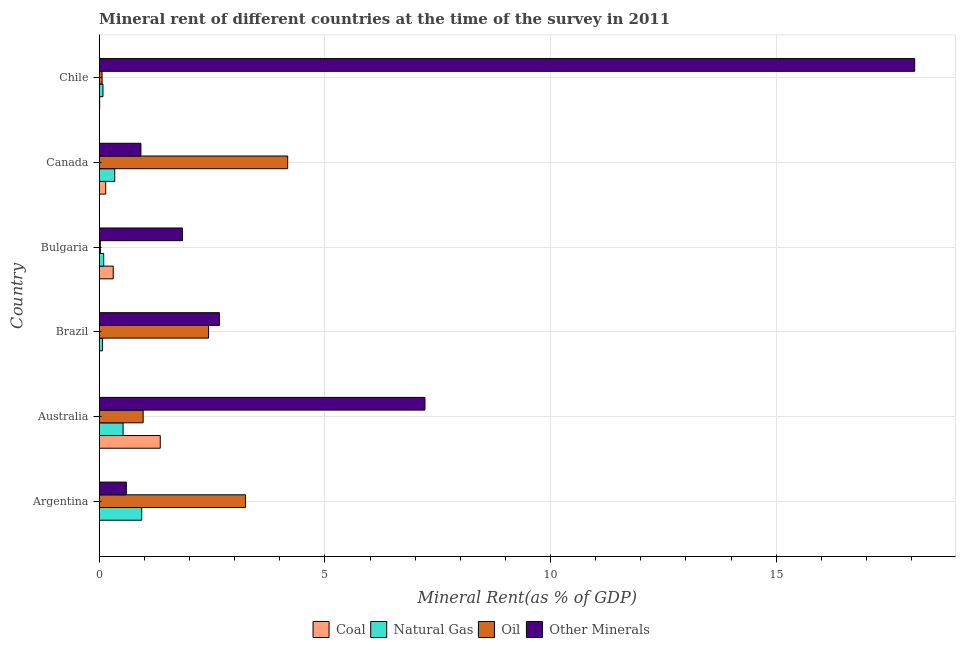How many groups of bars are there?
Provide a short and direct response. 6. Are the number of bars per tick equal to the number of legend labels?
Make the answer very short. Yes. Are the number of bars on each tick of the Y-axis equal?
Ensure brevity in your answer.  Yes. How many bars are there on the 2nd tick from the top?
Provide a succinct answer. 4. What is the natural gas rent in Australia?
Provide a short and direct response. 0.53. Across all countries, what is the maximum natural gas rent?
Give a very brief answer. 0.94. Across all countries, what is the minimum coal rent?
Keep it short and to the point. 0. In which country was the coal rent maximum?
Provide a succinct answer. Australia. In which country was the natural gas rent minimum?
Give a very brief answer. Brazil. What is the total coal rent in the graph?
Ensure brevity in your answer.  1.82. What is the difference between the  rent of other minerals in Argentina and that in Chile?
Offer a very short reply. -17.47. What is the difference between the  rent of other minerals in Australia and the coal rent in Brazil?
Offer a terse response. 7.21. What is the average coal rent per country?
Offer a terse response. 0.3. What is the difference between the oil rent and coal rent in Bulgaria?
Give a very brief answer. -0.29. In how many countries, is the  rent of other minerals greater than 2 %?
Make the answer very short. 3. What is the ratio of the coal rent in Australia to that in Chile?
Ensure brevity in your answer.  144.48. Is the oil rent in Argentina less than that in Bulgaria?
Offer a very short reply. No. What is the difference between the highest and the second highest natural gas rent?
Your response must be concise. 0.41. What is the difference between the highest and the lowest oil rent?
Ensure brevity in your answer.  4.15. In how many countries, is the coal rent greater than the average coal rent taken over all countries?
Ensure brevity in your answer.  2. Is the sum of the oil rent in Bulgaria and Chile greater than the maximum coal rent across all countries?
Provide a short and direct response. No. What does the 2nd bar from the top in Canada represents?
Provide a succinct answer. Oil. What does the 4th bar from the bottom in Chile represents?
Ensure brevity in your answer.  Other Minerals. Is it the case that in every country, the sum of the coal rent and natural gas rent is greater than the oil rent?
Provide a succinct answer. No. Are all the bars in the graph horizontal?
Offer a very short reply. Yes. How many countries are there in the graph?
Keep it short and to the point. 6. What is the difference between two consecutive major ticks on the X-axis?
Offer a terse response. 5. Are the values on the major ticks of X-axis written in scientific E-notation?
Make the answer very short. No. Does the graph contain any zero values?
Provide a short and direct response. No. Does the graph contain grids?
Your answer should be compact. Yes. Where does the legend appear in the graph?
Your response must be concise. Bottom center. How are the legend labels stacked?
Keep it short and to the point. Horizontal. What is the title of the graph?
Your answer should be compact. Mineral rent of different countries at the time of the survey in 2011. What is the label or title of the X-axis?
Provide a succinct answer. Mineral Rent(as % of GDP). What is the Mineral Rent(as % of GDP) in Coal in Argentina?
Make the answer very short. 0. What is the Mineral Rent(as % of GDP) in Natural Gas in Argentina?
Provide a short and direct response. 0.94. What is the Mineral Rent(as % of GDP) of Oil in Argentina?
Ensure brevity in your answer.  3.24. What is the Mineral Rent(as % of GDP) of Other Minerals in Argentina?
Make the answer very short. 0.6. What is the Mineral Rent(as % of GDP) in Coal in Australia?
Give a very brief answer. 1.35. What is the Mineral Rent(as % of GDP) in Natural Gas in Australia?
Your response must be concise. 0.53. What is the Mineral Rent(as % of GDP) in Oil in Australia?
Keep it short and to the point. 0.97. What is the Mineral Rent(as % of GDP) of Other Minerals in Australia?
Provide a short and direct response. 7.22. What is the Mineral Rent(as % of GDP) in Coal in Brazil?
Make the answer very short. 0. What is the Mineral Rent(as % of GDP) in Natural Gas in Brazil?
Offer a very short reply. 0.07. What is the Mineral Rent(as % of GDP) in Oil in Brazil?
Provide a succinct answer. 2.42. What is the Mineral Rent(as % of GDP) of Other Minerals in Brazil?
Your response must be concise. 2.66. What is the Mineral Rent(as % of GDP) of Coal in Bulgaria?
Make the answer very short. 0.31. What is the Mineral Rent(as % of GDP) of Natural Gas in Bulgaria?
Ensure brevity in your answer.  0.1. What is the Mineral Rent(as % of GDP) in Oil in Bulgaria?
Provide a succinct answer. 0.02. What is the Mineral Rent(as % of GDP) in Other Minerals in Bulgaria?
Give a very brief answer. 1.84. What is the Mineral Rent(as % of GDP) in Coal in Canada?
Give a very brief answer. 0.14. What is the Mineral Rent(as % of GDP) in Natural Gas in Canada?
Offer a very short reply. 0.34. What is the Mineral Rent(as % of GDP) of Oil in Canada?
Make the answer very short. 4.18. What is the Mineral Rent(as % of GDP) of Other Minerals in Canada?
Offer a very short reply. 0.92. What is the Mineral Rent(as % of GDP) in Coal in Chile?
Your answer should be very brief. 0.01. What is the Mineral Rent(as % of GDP) in Natural Gas in Chile?
Your answer should be compact. 0.08. What is the Mineral Rent(as % of GDP) of Oil in Chile?
Offer a terse response. 0.06. What is the Mineral Rent(as % of GDP) in Other Minerals in Chile?
Provide a short and direct response. 18.07. Across all countries, what is the maximum Mineral Rent(as % of GDP) of Coal?
Your response must be concise. 1.35. Across all countries, what is the maximum Mineral Rent(as % of GDP) in Natural Gas?
Offer a very short reply. 0.94. Across all countries, what is the maximum Mineral Rent(as % of GDP) in Oil?
Offer a very short reply. 4.18. Across all countries, what is the maximum Mineral Rent(as % of GDP) of Other Minerals?
Your answer should be very brief. 18.07. Across all countries, what is the minimum Mineral Rent(as % of GDP) of Coal?
Offer a terse response. 0. Across all countries, what is the minimum Mineral Rent(as % of GDP) of Natural Gas?
Your answer should be compact. 0.07. Across all countries, what is the minimum Mineral Rent(as % of GDP) in Oil?
Offer a terse response. 0.02. Across all countries, what is the minimum Mineral Rent(as % of GDP) in Other Minerals?
Offer a very short reply. 0.6. What is the total Mineral Rent(as % of GDP) of Coal in the graph?
Your answer should be compact. 1.82. What is the total Mineral Rent(as % of GDP) of Natural Gas in the graph?
Keep it short and to the point. 2.07. What is the total Mineral Rent(as % of GDP) in Oil in the graph?
Your response must be concise. 10.9. What is the total Mineral Rent(as % of GDP) of Other Minerals in the graph?
Ensure brevity in your answer.  31.32. What is the difference between the Mineral Rent(as % of GDP) in Coal in Argentina and that in Australia?
Your answer should be very brief. -1.35. What is the difference between the Mineral Rent(as % of GDP) in Natural Gas in Argentina and that in Australia?
Your answer should be compact. 0.41. What is the difference between the Mineral Rent(as % of GDP) in Oil in Argentina and that in Australia?
Your answer should be compact. 2.27. What is the difference between the Mineral Rent(as % of GDP) in Other Minerals in Argentina and that in Australia?
Make the answer very short. -6.62. What is the difference between the Mineral Rent(as % of GDP) in Coal in Argentina and that in Brazil?
Your answer should be compact. -0. What is the difference between the Mineral Rent(as % of GDP) of Natural Gas in Argentina and that in Brazil?
Offer a very short reply. 0.87. What is the difference between the Mineral Rent(as % of GDP) of Oil in Argentina and that in Brazil?
Offer a terse response. 0.82. What is the difference between the Mineral Rent(as % of GDP) of Other Minerals in Argentina and that in Brazil?
Your answer should be very brief. -2.06. What is the difference between the Mineral Rent(as % of GDP) in Coal in Argentina and that in Bulgaria?
Provide a succinct answer. -0.31. What is the difference between the Mineral Rent(as % of GDP) of Natural Gas in Argentina and that in Bulgaria?
Your answer should be compact. 0.84. What is the difference between the Mineral Rent(as % of GDP) of Oil in Argentina and that in Bulgaria?
Your answer should be compact. 3.22. What is the difference between the Mineral Rent(as % of GDP) in Other Minerals in Argentina and that in Bulgaria?
Make the answer very short. -1.24. What is the difference between the Mineral Rent(as % of GDP) of Coal in Argentina and that in Canada?
Offer a terse response. -0.14. What is the difference between the Mineral Rent(as % of GDP) of Natural Gas in Argentina and that in Canada?
Offer a very short reply. 0.6. What is the difference between the Mineral Rent(as % of GDP) of Oil in Argentina and that in Canada?
Your answer should be compact. -0.94. What is the difference between the Mineral Rent(as % of GDP) of Other Minerals in Argentina and that in Canada?
Provide a short and direct response. -0.32. What is the difference between the Mineral Rent(as % of GDP) in Coal in Argentina and that in Chile?
Your answer should be compact. -0.01. What is the difference between the Mineral Rent(as % of GDP) in Natural Gas in Argentina and that in Chile?
Your answer should be compact. 0.86. What is the difference between the Mineral Rent(as % of GDP) in Oil in Argentina and that in Chile?
Ensure brevity in your answer.  3.18. What is the difference between the Mineral Rent(as % of GDP) of Other Minerals in Argentina and that in Chile?
Your answer should be very brief. -17.47. What is the difference between the Mineral Rent(as % of GDP) of Coal in Australia and that in Brazil?
Give a very brief answer. 1.35. What is the difference between the Mineral Rent(as % of GDP) of Natural Gas in Australia and that in Brazil?
Provide a succinct answer. 0.45. What is the difference between the Mineral Rent(as % of GDP) of Oil in Australia and that in Brazil?
Keep it short and to the point. -1.45. What is the difference between the Mineral Rent(as % of GDP) in Other Minerals in Australia and that in Brazil?
Provide a short and direct response. 4.55. What is the difference between the Mineral Rent(as % of GDP) of Coal in Australia and that in Bulgaria?
Offer a very short reply. 1.04. What is the difference between the Mineral Rent(as % of GDP) in Natural Gas in Australia and that in Bulgaria?
Provide a succinct answer. 0.43. What is the difference between the Mineral Rent(as % of GDP) in Oil in Australia and that in Bulgaria?
Your answer should be compact. 0.95. What is the difference between the Mineral Rent(as % of GDP) in Other Minerals in Australia and that in Bulgaria?
Your answer should be compact. 5.37. What is the difference between the Mineral Rent(as % of GDP) of Coal in Australia and that in Canada?
Offer a terse response. 1.21. What is the difference between the Mineral Rent(as % of GDP) in Natural Gas in Australia and that in Canada?
Make the answer very short. 0.18. What is the difference between the Mineral Rent(as % of GDP) in Oil in Australia and that in Canada?
Offer a terse response. -3.2. What is the difference between the Mineral Rent(as % of GDP) in Other Minerals in Australia and that in Canada?
Your answer should be very brief. 6.29. What is the difference between the Mineral Rent(as % of GDP) in Coal in Australia and that in Chile?
Your answer should be compact. 1.34. What is the difference between the Mineral Rent(as % of GDP) in Natural Gas in Australia and that in Chile?
Offer a terse response. 0.45. What is the difference between the Mineral Rent(as % of GDP) in Oil in Australia and that in Chile?
Provide a short and direct response. 0.91. What is the difference between the Mineral Rent(as % of GDP) in Other Minerals in Australia and that in Chile?
Provide a succinct answer. -10.85. What is the difference between the Mineral Rent(as % of GDP) of Coal in Brazil and that in Bulgaria?
Provide a short and direct response. -0.31. What is the difference between the Mineral Rent(as % of GDP) in Natural Gas in Brazil and that in Bulgaria?
Provide a short and direct response. -0.03. What is the difference between the Mineral Rent(as % of GDP) in Oil in Brazil and that in Bulgaria?
Ensure brevity in your answer.  2.4. What is the difference between the Mineral Rent(as % of GDP) in Other Minerals in Brazil and that in Bulgaria?
Your answer should be compact. 0.82. What is the difference between the Mineral Rent(as % of GDP) in Coal in Brazil and that in Canada?
Provide a short and direct response. -0.14. What is the difference between the Mineral Rent(as % of GDP) of Natural Gas in Brazil and that in Canada?
Your answer should be very brief. -0.27. What is the difference between the Mineral Rent(as % of GDP) in Oil in Brazil and that in Canada?
Give a very brief answer. -1.75. What is the difference between the Mineral Rent(as % of GDP) of Other Minerals in Brazil and that in Canada?
Your response must be concise. 1.74. What is the difference between the Mineral Rent(as % of GDP) of Coal in Brazil and that in Chile?
Provide a short and direct response. -0.01. What is the difference between the Mineral Rent(as % of GDP) of Natural Gas in Brazil and that in Chile?
Offer a terse response. -0.01. What is the difference between the Mineral Rent(as % of GDP) in Oil in Brazil and that in Chile?
Your answer should be compact. 2.36. What is the difference between the Mineral Rent(as % of GDP) in Other Minerals in Brazil and that in Chile?
Your answer should be compact. -15.4. What is the difference between the Mineral Rent(as % of GDP) in Natural Gas in Bulgaria and that in Canada?
Make the answer very short. -0.24. What is the difference between the Mineral Rent(as % of GDP) of Oil in Bulgaria and that in Canada?
Offer a terse response. -4.15. What is the difference between the Mineral Rent(as % of GDP) of Other Minerals in Bulgaria and that in Canada?
Provide a succinct answer. 0.92. What is the difference between the Mineral Rent(as % of GDP) of Coal in Bulgaria and that in Chile?
Ensure brevity in your answer.  0.3. What is the difference between the Mineral Rent(as % of GDP) of Natural Gas in Bulgaria and that in Chile?
Make the answer very short. 0.02. What is the difference between the Mineral Rent(as % of GDP) in Oil in Bulgaria and that in Chile?
Offer a terse response. -0.04. What is the difference between the Mineral Rent(as % of GDP) in Other Minerals in Bulgaria and that in Chile?
Your response must be concise. -16.23. What is the difference between the Mineral Rent(as % of GDP) in Coal in Canada and that in Chile?
Your answer should be compact. 0.13. What is the difference between the Mineral Rent(as % of GDP) in Natural Gas in Canada and that in Chile?
Keep it short and to the point. 0.26. What is the difference between the Mineral Rent(as % of GDP) of Oil in Canada and that in Chile?
Your response must be concise. 4.11. What is the difference between the Mineral Rent(as % of GDP) in Other Minerals in Canada and that in Chile?
Your response must be concise. -17.15. What is the difference between the Mineral Rent(as % of GDP) of Coal in Argentina and the Mineral Rent(as % of GDP) of Natural Gas in Australia?
Provide a succinct answer. -0.53. What is the difference between the Mineral Rent(as % of GDP) of Coal in Argentina and the Mineral Rent(as % of GDP) of Oil in Australia?
Offer a terse response. -0.97. What is the difference between the Mineral Rent(as % of GDP) in Coal in Argentina and the Mineral Rent(as % of GDP) in Other Minerals in Australia?
Give a very brief answer. -7.22. What is the difference between the Mineral Rent(as % of GDP) in Natural Gas in Argentina and the Mineral Rent(as % of GDP) in Oil in Australia?
Your answer should be very brief. -0.03. What is the difference between the Mineral Rent(as % of GDP) in Natural Gas in Argentina and the Mineral Rent(as % of GDP) in Other Minerals in Australia?
Keep it short and to the point. -6.28. What is the difference between the Mineral Rent(as % of GDP) of Oil in Argentina and the Mineral Rent(as % of GDP) of Other Minerals in Australia?
Your answer should be very brief. -3.98. What is the difference between the Mineral Rent(as % of GDP) of Coal in Argentina and the Mineral Rent(as % of GDP) of Natural Gas in Brazil?
Your response must be concise. -0.07. What is the difference between the Mineral Rent(as % of GDP) in Coal in Argentina and the Mineral Rent(as % of GDP) in Oil in Brazil?
Offer a terse response. -2.42. What is the difference between the Mineral Rent(as % of GDP) in Coal in Argentina and the Mineral Rent(as % of GDP) in Other Minerals in Brazil?
Ensure brevity in your answer.  -2.66. What is the difference between the Mineral Rent(as % of GDP) of Natural Gas in Argentina and the Mineral Rent(as % of GDP) of Oil in Brazil?
Offer a terse response. -1.48. What is the difference between the Mineral Rent(as % of GDP) of Natural Gas in Argentina and the Mineral Rent(as % of GDP) of Other Minerals in Brazil?
Your answer should be compact. -1.72. What is the difference between the Mineral Rent(as % of GDP) of Oil in Argentina and the Mineral Rent(as % of GDP) of Other Minerals in Brazil?
Provide a short and direct response. 0.58. What is the difference between the Mineral Rent(as % of GDP) of Coal in Argentina and the Mineral Rent(as % of GDP) of Natural Gas in Bulgaria?
Provide a succinct answer. -0.1. What is the difference between the Mineral Rent(as % of GDP) of Coal in Argentina and the Mineral Rent(as % of GDP) of Oil in Bulgaria?
Ensure brevity in your answer.  -0.02. What is the difference between the Mineral Rent(as % of GDP) in Coal in Argentina and the Mineral Rent(as % of GDP) in Other Minerals in Bulgaria?
Offer a very short reply. -1.84. What is the difference between the Mineral Rent(as % of GDP) of Natural Gas in Argentina and the Mineral Rent(as % of GDP) of Oil in Bulgaria?
Your answer should be compact. 0.92. What is the difference between the Mineral Rent(as % of GDP) of Natural Gas in Argentina and the Mineral Rent(as % of GDP) of Other Minerals in Bulgaria?
Provide a short and direct response. -0.9. What is the difference between the Mineral Rent(as % of GDP) of Oil in Argentina and the Mineral Rent(as % of GDP) of Other Minerals in Bulgaria?
Provide a short and direct response. 1.4. What is the difference between the Mineral Rent(as % of GDP) in Coal in Argentina and the Mineral Rent(as % of GDP) in Natural Gas in Canada?
Offer a terse response. -0.34. What is the difference between the Mineral Rent(as % of GDP) of Coal in Argentina and the Mineral Rent(as % of GDP) of Oil in Canada?
Your answer should be very brief. -4.18. What is the difference between the Mineral Rent(as % of GDP) in Coal in Argentina and the Mineral Rent(as % of GDP) in Other Minerals in Canada?
Provide a succinct answer. -0.92. What is the difference between the Mineral Rent(as % of GDP) in Natural Gas in Argentina and the Mineral Rent(as % of GDP) in Oil in Canada?
Your response must be concise. -3.23. What is the difference between the Mineral Rent(as % of GDP) in Natural Gas in Argentina and the Mineral Rent(as % of GDP) in Other Minerals in Canada?
Keep it short and to the point. 0.02. What is the difference between the Mineral Rent(as % of GDP) in Oil in Argentina and the Mineral Rent(as % of GDP) in Other Minerals in Canada?
Offer a terse response. 2.32. What is the difference between the Mineral Rent(as % of GDP) in Coal in Argentina and the Mineral Rent(as % of GDP) in Natural Gas in Chile?
Make the answer very short. -0.08. What is the difference between the Mineral Rent(as % of GDP) of Coal in Argentina and the Mineral Rent(as % of GDP) of Oil in Chile?
Ensure brevity in your answer.  -0.06. What is the difference between the Mineral Rent(as % of GDP) of Coal in Argentina and the Mineral Rent(as % of GDP) of Other Minerals in Chile?
Your response must be concise. -18.07. What is the difference between the Mineral Rent(as % of GDP) of Natural Gas in Argentina and the Mineral Rent(as % of GDP) of Oil in Chile?
Ensure brevity in your answer.  0.88. What is the difference between the Mineral Rent(as % of GDP) in Natural Gas in Argentina and the Mineral Rent(as % of GDP) in Other Minerals in Chile?
Make the answer very short. -17.13. What is the difference between the Mineral Rent(as % of GDP) in Oil in Argentina and the Mineral Rent(as % of GDP) in Other Minerals in Chile?
Provide a succinct answer. -14.83. What is the difference between the Mineral Rent(as % of GDP) in Coal in Australia and the Mineral Rent(as % of GDP) in Natural Gas in Brazil?
Offer a very short reply. 1.28. What is the difference between the Mineral Rent(as % of GDP) in Coal in Australia and the Mineral Rent(as % of GDP) in Oil in Brazil?
Offer a very short reply. -1.07. What is the difference between the Mineral Rent(as % of GDP) of Coal in Australia and the Mineral Rent(as % of GDP) of Other Minerals in Brazil?
Provide a succinct answer. -1.31. What is the difference between the Mineral Rent(as % of GDP) in Natural Gas in Australia and the Mineral Rent(as % of GDP) in Oil in Brazil?
Give a very brief answer. -1.89. What is the difference between the Mineral Rent(as % of GDP) of Natural Gas in Australia and the Mineral Rent(as % of GDP) of Other Minerals in Brazil?
Provide a short and direct response. -2.14. What is the difference between the Mineral Rent(as % of GDP) of Oil in Australia and the Mineral Rent(as % of GDP) of Other Minerals in Brazil?
Your answer should be very brief. -1.69. What is the difference between the Mineral Rent(as % of GDP) in Coal in Australia and the Mineral Rent(as % of GDP) in Natural Gas in Bulgaria?
Your answer should be compact. 1.25. What is the difference between the Mineral Rent(as % of GDP) in Coal in Australia and the Mineral Rent(as % of GDP) in Oil in Bulgaria?
Ensure brevity in your answer.  1.33. What is the difference between the Mineral Rent(as % of GDP) in Coal in Australia and the Mineral Rent(as % of GDP) in Other Minerals in Bulgaria?
Provide a short and direct response. -0.49. What is the difference between the Mineral Rent(as % of GDP) of Natural Gas in Australia and the Mineral Rent(as % of GDP) of Oil in Bulgaria?
Your answer should be compact. 0.5. What is the difference between the Mineral Rent(as % of GDP) of Natural Gas in Australia and the Mineral Rent(as % of GDP) of Other Minerals in Bulgaria?
Keep it short and to the point. -1.32. What is the difference between the Mineral Rent(as % of GDP) of Oil in Australia and the Mineral Rent(as % of GDP) of Other Minerals in Bulgaria?
Your response must be concise. -0.87. What is the difference between the Mineral Rent(as % of GDP) of Coal in Australia and the Mineral Rent(as % of GDP) of Natural Gas in Canada?
Provide a short and direct response. 1.01. What is the difference between the Mineral Rent(as % of GDP) in Coal in Australia and the Mineral Rent(as % of GDP) in Oil in Canada?
Ensure brevity in your answer.  -2.82. What is the difference between the Mineral Rent(as % of GDP) in Coal in Australia and the Mineral Rent(as % of GDP) in Other Minerals in Canada?
Your answer should be compact. 0.43. What is the difference between the Mineral Rent(as % of GDP) of Natural Gas in Australia and the Mineral Rent(as % of GDP) of Oil in Canada?
Your response must be concise. -3.65. What is the difference between the Mineral Rent(as % of GDP) of Natural Gas in Australia and the Mineral Rent(as % of GDP) of Other Minerals in Canada?
Ensure brevity in your answer.  -0.4. What is the difference between the Mineral Rent(as % of GDP) in Oil in Australia and the Mineral Rent(as % of GDP) in Other Minerals in Canada?
Give a very brief answer. 0.05. What is the difference between the Mineral Rent(as % of GDP) of Coal in Australia and the Mineral Rent(as % of GDP) of Natural Gas in Chile?
Your answer should be very brief. 1.27. What is the difference between the Mineral Rent(as % of GDP) of Coal in Australia and the Mineral Rent(as % of GDP) of Oil in Chile?
Ensure brevity in your answer.  1.29. What is the difference between the Mineral Rent(as % of GDP) in Coal in Australia and the Mineral Rent(as % of GDP) in Other Minerals in Chile?
Your answer should be very brief. -16.72. What is the difference between the Mineral Rent(as % of GDP) in Natural Gas in Australia and the Mineral Rent(as % of GDP) in Oil in Chile?
Ensure brevity in your answer.  0.47. What is the difference between the Mineral Rent(as % of GDP) in Natural Gas in Australia and the Mineral Rent(as % of GDP) in Other Minerals in Chile?
Provide a succinct answer. -17.54. What is the difference between the Mineral Rent(as % of GDP) in Oil in Australia and the Mineral Rent(as % of GDP) in Other Minerals in Chile?
Your answer should be very brief. -17.1. What is the difference between the Mineral Rent(as % of GDP) of Coal in Brazil and the Mineral Rent(as % of GDP) of Natural Gas in Bulgaria?
Your response must be concise. -0.1. What is the difference between the Mineral Rent(as % of GDP) of Coal in Brazil and the Mineral Rent(as % of GDP) of Oil in Bulgaria?
Make the answer very short. -0.02. What is the difference between the Mineral Rent(as % of GDP) of Coal in Brazil and the Mineral Rent(as % of GDP) of Other Minerals in Bulgaria?
Your response must be concise. -1.84. What is the difference between the Mineral Rent(as % of GDP) of Natural Gas in Brazil and the Mineral Rent(as % of GDP) of Oil in Bulgaria?
Make the answer very short. 0.05. What is the difference between the Mineral Rent(as % of GDP) in Natural Gas in Brazil and the Mineral Rent(as % of GDP) in Other Minerals in Bulgaria?
Offer a terse response. -1.77. What is the difference between the Mineral Rent(as % of GDP) in Oil in Brazil and the Mineral Rent(as % of GDP) in Other Minerals in Bulgaria?
Make the answer very short. 0.58. What is the difference between the Mineral Rent(as % of GDP) of Coal in Brazil and the Mineral Rent(as % of GDP) of Natural Gas in Canada?
Offer a very short reply. -0.34. What is the difference between the Mineral Rent(as % of GDP) in Coal in Brazil and the Mineral Rent(as % of GDP) in Oil in Canada?
Ensure brevity in your answer.  -4.17. What is the difference between the Mineral Rent(as % of GDP) in Coal in Brazil and the Mineral Rent(as % of GDP) in Other Minerals in Canada?
Provide a succinct answer. -0.92. What is the difference between the Mineral Rent(as % of GDP) in Natural Gas in Brazil and the Mineral Rent(as % of GDP) in Oil in Canada?
Your answer should be compact. -4.1. What is the difference between the Mineral Rent(as % of GDP) in Natural Gas in Brazil and the Mineral Rent(as % of GDP) in Other Minerals in Canada?
Your answer should be compact. -0.85. What is the difference between the Mineral Rent(as % of GDP) of Oil in Brazil and the Mineral Rent(as % of GDP) of Other Minerals in Canada?
Offer a terse response. 1.5. What is the difference between the Mineral Rent(as % of GDP) in Coal in Brazil and the Mineral Rent(as % of GDP) in Natural Gas in Chile?
Your answer should be very brief. -0.08. What is the difference between the Mineral Rent(as % of GDP) of Coal in Brazil and the Mineral Rent(as % of GDP) of Oil in Chile?
Your response must be concise. -0.06. What is the difference between the Mineral Rent(as % of GDP) in Coal in Brazil and the Mineral Rent(as % of GDP) in Other Minerals in Chile?
Give a very brief answer. -18.07. What is the difference between the Mineral Rent(as % of GDP) in Natural Gas in Brazil and the Mineral Rent(as % of GDP) in Oil in Chile?
Give a very brief answer. 0.01. What is the difference between the Mineral Rent(as % of GDP) of Natural Gas in Brazil and the Mineral Rent(as % of GDP) of Other Minerals in Chile?
Keep it short and to the point. -18. What is the difference between the Mineral Rent(as % of GDP) of Oil in Brazil and the Mineral Rent(as % of GDP) of Other Minerals in Chile?
Your answer should be compact. -15.65. What is the difference between the Mineral Rent(as % of GDP) of Coal in Bulgaria and the Mineral Rent(as % of GDP) of Natural Gas in Canada?
Provide a succinct answer. -0.03. What is the difference between the Mineral Rent(as % of GDP) in Coal in Bulgaria and the Mineral Rent(as % of GDP) in Oil in Canada?
Your answer should be compact. -3.87. What is the difference between the Mineral Rent(as % of GDP) in Coal in Bulgaria and the Mineral Rent(as % of GDP) in Other Minerals in Canada?
Provide a succinct answer. -0.61. What is the difference between the Mineral Rent(as % of GDP) in Natural Gas in Bulgaria and the Mineral Rent(as % of GDP) in Oil in Canada?
Provide a succinct answer. -4.08. What is the difference between the Mineral Rent(as % of GDP) of Natural Gas in Bulgaria and the Mineral Rent(as % of GDP) of Other Minerals in Canada?
Provide a succinct answer. -0.82. What is the difference between the Mineral Rent(as % of GDP) of Oil in Bulgaria and the Mineral Rent(as % of GDP) of Other Minerals in Canada?
Ensure brevity in your answer.  -0.9. What is the difference between the Mineral Rent(as % of GDP) in Coal in Bulgaria and the Mineral Rent(as % of GDP) in Natural Gas in Chile?
Your answer should be very brief. 0.23. What is the difference between the Mineral Rent(as % of GDP) in Coal in Bulgaria and the Mineral Rent(as % of GDP) in Oil in Chile?
Your answer should be compact. 0.25. What is the difference between the Mineral Rent(as % of GDP) in Coal in Bulgaria and the Mineral Rent(as % of GDP) in Other Minerals in Chile?
Ensure brevity in your answer.  -17.76. What is the difference between the Mineral Rent(as % of GDP) in Natural Gas in Bulgaria and the Mineral Rent(as % of GDP) in Oil in Chile?
Provide a short and direct response. 0.04. What is the difference between the Mineral Rent(as % of GDP) of Natural Gas in Bulgaria and the Mineral Rent(as % of GDP) of Other Minerals in Chile?
Keep it short and to the point. -17.97. What is the difference between the Mineral Rent(as % of GDP) in Oil in Bulgaria and the Mineral Rent(as % of GDP) in Other Minerals in Chile?
Offer a very short reply. -18.05. What is the difference between the Mineral Rent(as % of GDP) in Coal in Canada and the Mineral Rent(as % of GDP) in Natural Gas in Chile?
Your answer should be very brief. 0.06. What is the difference between the Mineral Rent(as % of GDP) in Coal in Canada and the Mineral Rent(as % of GDP) in Oil in Chile?
Offer a terse response. 0.08. What is the difference between the Mineral Rent(as % of GDP) of Coal in Canada and the Mineral Rent(as % of GDP) of Other Minerals in Chile?
Ensure brevity in your answer.  -17.93. What is the difference between the Mineral Rent(as % of GDP) of Natural Gas in Canada and the Mineral Rent(as % of GDP) of Oil in Chile?
Your answer should be compact. 0.28. What is the difference between the Mineral Rent(as % of GDP) in Natural Gas in Canada and the Mineral Rent(as % of GDP) in Other Minerals in Chile?
Your response must be concise. -17.73. What is the difference between the Mineral Rent(as % of GDP) in Oil in Canada and the Mineral Rent(as % of GDP) in Other Minerals in Chile?
Your answer should be very brief. -13.89. What is the average Mineral Rent(as % of GDP) of Coal per country?
Make the answer very short. 0.3. What is the average Mineral Rent(as % of GDP) in Natural Gas per country?
Provide a succinct answer. 0.35. What is the average Mineral Rent(as % of GDP) of Oil per country?
Ensure brevity in your answer.  1.82. What is the average Mineral Rent(as % of GDP) in Other Minerals per country?
Provide a succinct answer. 5.22. What is the difference between the Mineral Rent(as % of GDP) in Coal and Mineral Rent(as % of GDP) in Natural Gas in Argentina?
Your answer should be compact. -0.94. What is the difference between the Mineral Rent(as % of GDP) of Coal and Mineral Rent(as % of GDP) of Oil in Argentina?
Offer a terse response. -3.24. What is the difference between the Mineral Rent(as % of GDP) in Coal and Mineral Rent(as % of GDP) in Other Minerals in Argentina?
Provide a succinct answer. -0.6. What is the difference between the Mineral Rent(as % of GDP) of Natural Gas and Mineral Rent(as % of GDP) of Oil in Argentina?
Offer a very short reply. -2.3. What is the difference between the Mineral Rent(as % of GDP) of Natural Gas and Mineral Rent(as % of GDP) of Other Minerals in Argentina?
Keep it short and to the point. 0.34. What is the difference between the Mineral Rent(as % of GDP) of Oil and Mineral Rent(as % of GDP) of Other Minerals in Argentina?
Offer a very short reply. 2.64. What is the difference between the Mineral Rent(as % of GDP) of Coal and Mineral Rent(as % of GDP) of Natural Gas in Australia?
Your response must be concise. 0.82. What is the difference between the Mineral Rent(as % of GDP) of Coal and Mineral Rent(as % of GDP) of Oil in Australia?
Keep it short and to the point. 0.38. What is the difference between the Mineral Rent(as % of GDP) in Coal and Mineral Rent(as % of GDP) in Other Minerals in Australia?
Keep it short and to the point. -5.87. What is the difference between the Mineral Rent(as % of GDP) of Natural Gas and Mineral Rent(as % of GDP) of Oil in Australia?
Your answer should be very brief. -0.44. What is the difference between the Mineral Rent(as % of GDP) of Natural Gas and Mineral Rent(as % of GDP) of Other Minerals in Australia?
Keep it short and to the point. -6.69. What is the difference between the Mineral Rent(as % of GDP) of Oil and Mineral Rent(as % of GDP) of Other Minerals in Australia?
Provide a short and direct response. -6.24. What is the difference between the Mineral Rent(as % of GDP) in Coal and Mineral Rent(as % of GDP) in Natural Gas in Brazil?
Provide a succinct answer. -0.07. What is the difference between the Mineral Rent(as % of GDP) of Coal and Mineral Rent(as % of GDP) of Oil in Brazil?
Provide a short and direct response. -2.42. What is the difference between the Mineral Rent(as % of GDP) of Coal and Mineral Rent(as % of GDP) of Other Minerals in Brazil?
Your answer should be very brief. -2.66. What is the difference between the Mineral Rent(as % of GDP) in Natural Gas and Mineral Rent(as % of GDP) in Oil in Brazil?
Make the answer very short. -2.35. What is the difference between the Mineral Rent(as % of GDP) of Natural Gas and Mineral Rent(as % of GDP) of Other Minerals in Brazil?
Offer a very short reply. -2.59. What is the difference between the Mineral Rent(as % of GDP) of Oil and Mineral Rent(as % of GDP) of Other Minerals in Brazil?
Provide a succinct answer. -0.24. What is the difference between the Mineral Rent(as % of GDP) of Coal and Mineral Rent(as % of GDP) of Natural Gas in Bulgaria?
Keep it short and to the point. 0.21. What is the difference between the Mineral Rent(as % of GDP) in Coal and Mineral Rent(as % of GDP) in Oil in Bulgaria?
Give a very brief answer. 0.29. What is the difference between the Mineral Rent(as % of GDP) in Coal and Mineral Rent(as % of GDP) in Other Minerals in Bulgaria?
Your answer should be very brief. -1.53. What is the difference between the Mineral Rent(as % of GDP) in Natural Gas and Mineral Rent(as % of GDP) in Oil in Bulgaria?
Your answer should be compact. 0.08. What is the difference between the Mineral Rent(as % of GDP) of Natural Gas and Mineral Rent(as % of GDP) of Other Minerals in Bulgaria?
Provide a succinct answer. -1.75. What is the difference between the Mineral Rent(as % of GDP) in Oil and Mineral Rent(as % of GDP) in Other Minerals in Bulgaria?
Give a very brief answer. -1.82. What is the difference between the Mineral Rent(as % of GDP) of Coal and Mineral Rent(as % of GDP) of Natural Gas in Canada?
Ensure brevity in your answer.  -0.2. What is the difference between the Mineral Rent(as % of GDP) of Coal and Mineral Rent(as % of GDP) of Oil in Canada?
Offer a very short reply. -4.03. What is the difference between the Mineral Rent(as % of GDP) in Coal and Mineral Rent(as % of GDP) in Other Minerals in Canada?
Give a very brief answer. -0.78. What is the difference between the Mineral Rent(as % of GDP) of Natural Gas and Mineral Rent(as % of GDP) of Oil in Canada?
Your answer should be very brief. -3.83. What is the difference between the Mineral Rent(as % of GDP) in Natural Gas and Mineral Rent(as % of GDP) in Other Minerals in Canada?
Offer a terse response. -0.58. What is the difference between the Mineral Rent(as % of GDP) of Oil and Mineral Rent(as % of GDP) of Other Minerals in Canada?
Ensure brevity in your answer.  3.25. What is the difference between the Mineral Rent(as % of GDP) of Coal and Mineral Rent(as % of GDP) of Natural Gas in Chile?
Provide a succinct answer. -0.07. What is the difference between the Mineral Rent(as % of GDP) of Coal and Mineral Rent(as % of GDP) of Oil in Chile?
Offer a terse response. -0.05. What is the difference between the Mineral Rent(as % of GDP) in Coal and Mineral Rent(as % of GDP) in Other Minerals in Chile?
Ensure brevity in your answer.  -18.06. What is the difference between the Mineral Rent(as % of GDP) in Natural Gas and Mineral Rent(as % of GDP) in Oil in Chile?
Make the answer very short. 0.02. What is the difference between the Mineral Rent(as % of GDP) in Natural Gas and Mineral Rent(as % of GDP) in Other Minerals in Chile?
Keep it short and to the point. -17.99. What is the difference between the Mineral Rent(as % of GDP) in Oil and Mineral Rent(as % of GDP) in Other Minerals in Chile?
Give a very brief answer. -18.01. What is the ratio of the Mineral Rent(as % of GDP) in Coal in Argentina to that in Australia?
Ensure brevity in your answer.  0. What is the ratio of the Mineral Rent(as % of GDP) in Natural Gas in Argentina to that in Australia?
Your answer should be very brief. 1.78. What is the ratio of the Mineral Rent(as % of GDP) in Oil in Argentina to that in Australia?
Your response must be concise. 3.33. What is the ratio of the Mineral Rent(as % of GDP) of Other Minerals in Argentina to that in Australia?
Your answer should be compact. 0.08. What is the ratio of the Mineral Rent(as % of GDP) of Coal in Argentina to that in Brazil?
Make the answer very short. 0.24. What is the ratio of the Mineral Rent(as % of GDP) in Natural Gas in Argentina to that in Brazil?
Provide a short and direct response. 12.7. What is the ratio of the Mineral Rent(as % of GDP) in Oil in Argentina to that in Brazil?
Ensure brevity in your answer.  1.34. What is the ratio of the Mineral Rent(as % of GDP) of Other Minerals in Argentina to that in Brazil?
Offer a very short reply. 0.23. What is the ratio of the Mineral Rent(as % of GDP) of Coal in Argentina to that in Bulgaria?
Keep it short and to the point. 0. What is the ratio of the Mineral Rent(as % of GDP) in Natural Gas in Argentina to that in Bulgaria?
Give a very brief answer. 9.46. What is the ratio of the Mineral Rent(as % of GDP) of Oil in Argentina to that in Bulgaria?
Your answer should be very brief. 133.18. What is the ratio of the Mineral Rent(as % of GDP) in Other Minerals in Argentina to that in Bulgaria?
Offer a very short reply. 0.33. What is the ratio of the Mineral Rent(as % of GDP) in Coal in Argentina to that in Canada?
Offer a very short reply. 0.01. What is the ratio of the Mineral Rent(as % of GDP) in Natural Gas in Argentina to that in Canada?
Your response must be concise. 2.74. What is the ratio of the Mineral Rent(as % of GDP) in Oil in Argentina to that in Canada?
Your answer should be compact. 0.78. What is the ratio of the Mineral Rent(as % of GDP) of Other Minerals in Argentina to that in Canada?
Give a very brief answer. 0.65. What is the ratio of the Mineral Rent(as % of GDP) of Coal in Argentina to that in Chile?
Keep it short and to the point. 0.1. What is the ratio of the Mineral Rent(as % of GDP) in Natural Gas in Argentina to that in Chile?
Give a very brief answer. 11.31. What is the ratio of the Mineral Rent(as % of GDP) in Oil in Argentina to that in Chile?
Your response must be concise. 51.23. What is the ratio of the Mineral Rent(as % of GDP) in Other Minerals in Argentina to that in Chile?
Your response must be concise. 0.03. What is the ratio of the Mineral Rent(as % of GDP) of Coal in Australia to that in Brazil?
Keep it short and to the point. 364.89. What is the ratio of the Mineral Rent(as % of GDP) of Natural Gas in Australia to that in Brazil?
Ensure brevity in your answer.  7.13. What is the ratio of the Mineral Rent(as % of GDP) in Oil in Australia to that in Brazil?
Give a very brief answer. 0.4. What is the ratio of the Mineral Rent(as % of GDP) in Other Minerals in Australia to that in Brazil?
Give a very brief answer. 2.71. What is the ratio of the Mineral Rent(as % of GDP) in Coal in Australia to that in Bulgaria?
Offer a terse response. 4.36. What is the ratio of the Mineral Rent(as % of GDP) of Natural Gas in Australia to that in Bulgaria?
Ensure brevity in your answer.  5.31. What is the ratio of the Mineral Rent(as % of GDP) of Oil in Australia to that in Bulgaria?
Your answer should be very brief. 40.02. What is the ratio of the Mineral Rent(as % of GDP) of Other Minerals in Australia to that in Bulgaria?
Offer a terse response. 3.91. What is the ratio of the Mineral Rent(as % of GDP) of Coal in Australia to that in Canada?
Make the answer very short. 9.41. What is the ratio of the Mineral Rent(as % of GDP) in Natural Gas in Australia to that in Canada?
Provide a short and direct response. 1.54. What is the ratio of the Mineral Rent(as % of GDP) of Oil in Australia to that in Canada?
Your answer should be compact. 0.23. What is the ratio of the Mineral Rent(as % of GDP) in Other Minerals in Australia to that in Canada?
Your response must be concise. 7.81. What is the ratio of the Mineral Rent(as % of GDP) in Coal in Australia to that in Chile?
Make the answer very short. 144.48. What is the ratio of the Mineral Rent(as % of GDP) of Natural Gas in Australia to that in Chile?
Keep it short and to the point. 6.35. What is the ratio of the Mineral Rent(as % of GDP) in Oil in Australia to that in Chile?
Provide a succinct answer. 15.39. What is the ratio of the Mineral Rent(as % of GDP) in Other Minerals in Australia to that in Chile?
Offer a very short reply. 0.4. What is the ratio of the Mineral Rent(as % of GDP) of Coal in Brazil to that in Bulgaria?
Your response must be concise. 0.01. What is the ratio of the Mineral Rent(as % of GDP) of Natural Gas in Brazil to that in Bulgaria?
Your answer should be compact. 0.74. What is the ratio of the Mineral Rent(as % of GDP) of Oil in Brazil to that in Bulgaria?
Your answer should be very brief. 99.58. What is the ratio of the Mineral Rent(as % of GDP) of Other Minerals in Brazil to that in Bulgaria?
Give a very brief answer. 1.44. What is the ratio of the Mineral Rent(as % of GDP) in Coal in Brazil to that in Canada?
Provide a succinct answer. 0.03. What is the ratio of the Mineral Rent(as % of GDP) in Natural Gas in Brazil to that in Canada?
Ensure brevity in your answer.  0.22. What is the ratio of the Mineral Rent(as % of GDP) in Oil in Brazil to that in Canada?
Your response must be concise. 0.58. What is the ratio of the Mineral Rent(as % of GDP) in Other Minerals in Brazil to that in Canada?
Your answer should be very brief. 2.88. What is the ratio of the Mineral Rent(as % of GDP) of Coal in Brazil to that in Chile?
Make the answer very short. 0.4. What is the ratio of the Mineral Rent(as % of GDP) of Natural Gas in Brazil to that in Chile?
Offer a very short reply. 0.89. What is the ratio of the Mineral Rent(as % of GDP) in Oil in Brazil to that in Chile?
Offer a very short reply. 38.31. What is the ratio of the Mineral Rent(as % of GDP) of Other Minerals in Brazil to that in Chile?
Ensure brevity in your answer.  0.15. What is the ratio of the Mineral Rent(as % of GDP) in Coal in Bulgaria to that in Canada?
Offer a terse response. 2.16. What is the ratio of the Mineral Rent(as % of GDP) of Natural Gas in Bulgaria to that in Canada?
Your answer should be very brief. 0.29. What is the ratio of the Mineral Rent(as % of GDP) of Oil in Bulgaria to that in Canada?
Offer a very short reply. 0.01. What is the ratio of the Mineral Rent(as % of GDP) of Other Minerals in Bulgaria to that in Canada?
Your answer should be compact. 2. What is the ratio of the Mineral Rent(as % of GDP) in Coal in Bulgaria to that in Chile?
Give a very brief answer. 33.16. What is the ratio of the Mineral Rent(as % of GDP) in Natural Gas in Bulgaria to that in Chile?
Make the answer very short. 1.2. What is the ratio of the Mineral Rent(as % of GDP) in Oil in Bulgaria to that in Chile?
Give a very brief answer. 0.38. What is the ratio of the Mineral Rent(as % of GDP) of Other Minerals in Bulgaria to that in Chile?
Keep it short and to the point. 0.1. What is the ratio of the Mineral Rent(as % of GDP) in Coal in Canada to that in Chile?
Keep it short and to the point. 15.36. What is the ratio of the Mineral Rent(as % of GDP) in Natural Gas in Canada to that in Chile?
Your answer should be very brief. 4.13. What is the ratio of the Mineral Rent(as % of GDP) of Oil in Canada to that in Chile?
Your answer should be very brief. 66.02. What is the ratio of the Mineral Rent(as % of GDP) of Other Minerals in Canada to that in Chile?
Ensure brevity in your answer.  0.05. What is the difference between the highest and the second highest Mineral Rent(as % of GDP) of Coal?
Offer a very short reply. 1.04. What is the difference between the highest and the second highest Mineral Rent(as % of GDP) in Natural Gas?
Ensure brevity in your answer.  0.41. What is the difference between the highest and the second highest Mineral Rent(as % of GDP) in Oil?
Your answer should be compact. 0.94. What is the difference between the highest and the second highest Mineral Rent(as % of GDP) of Other Minerals?
Give a very brief answer. 10.85. What is the difference between the highest and the lowest Mineral Rent(as % of GDP) in Coal?
Your answer should be very brief. 1.35. What is the difference between the highest and the lowest Mineral Rent(as % of GDP) of Natural Gas?
Offer a very short reply. 0.87. What is the difference between the highest and the lowest Mineral Rent(as % of GDP) in Oil?
Offer a terse response. 4.15. What is the difference between the highest and the lowest Mineral Rent(as % of GDP) in Other Minerals?
Provide a short and direct response. 17.47. 